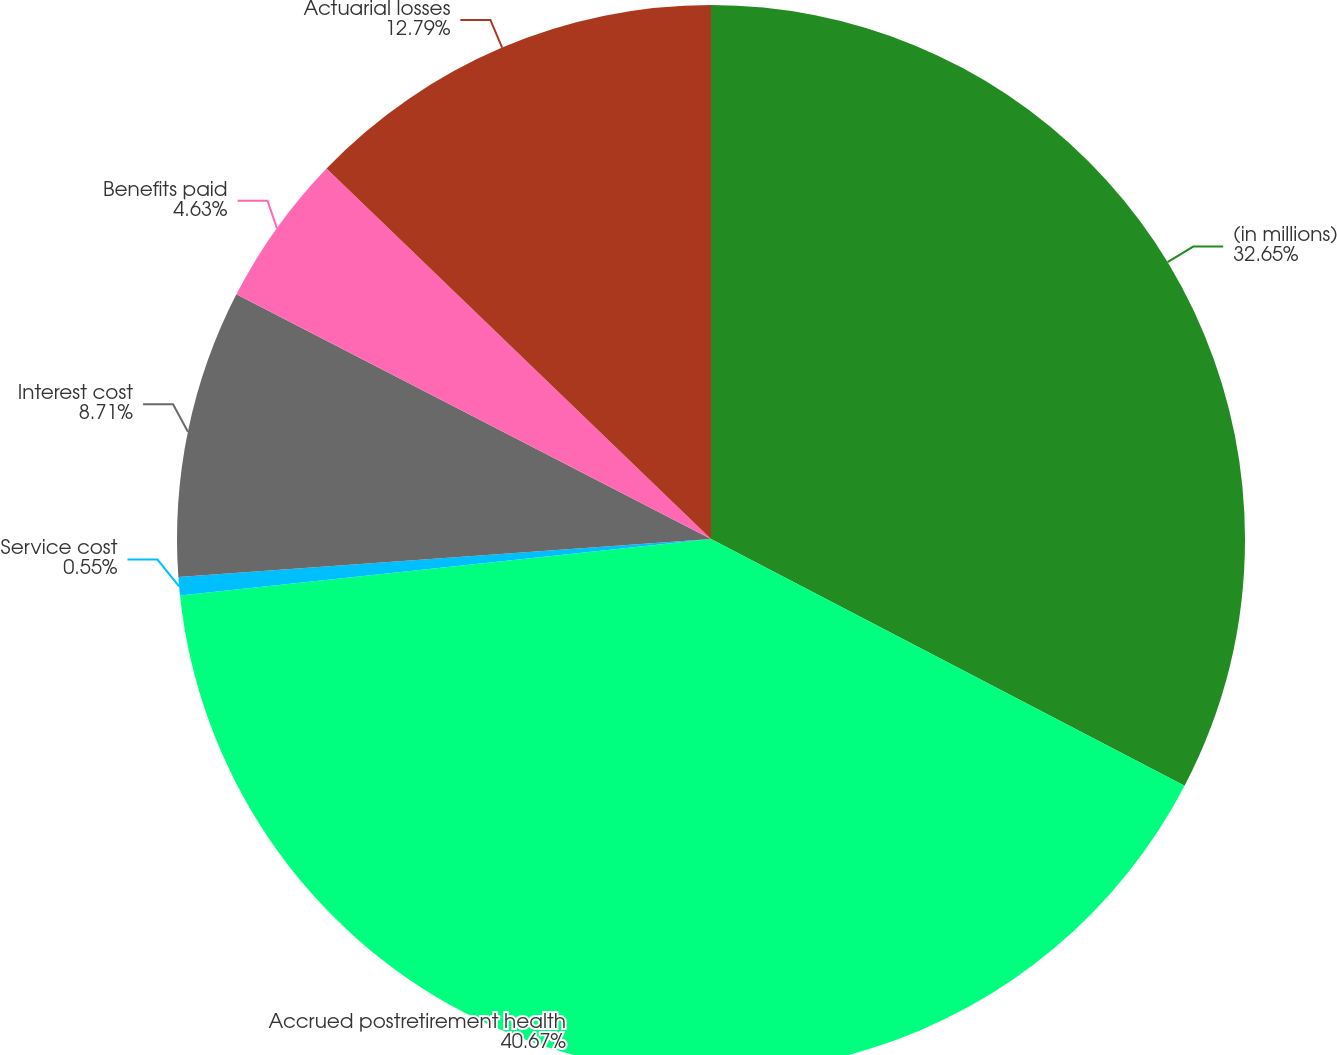<chart> <loc_0><loc_0><loc_500><loc_500><pie_chart><fcel>(in millions)<fcel>Accrued postretirement health<fcel>Service cost<fcel>Interest cost<fcel>Benefits paid<fcel>Actuarial losses<nl><fcel>32.64%<fcel>40.66%<fcel>0.55%<fcel>8.71%<fcel>4.63%<fcel>12.79%<nl></chart> 